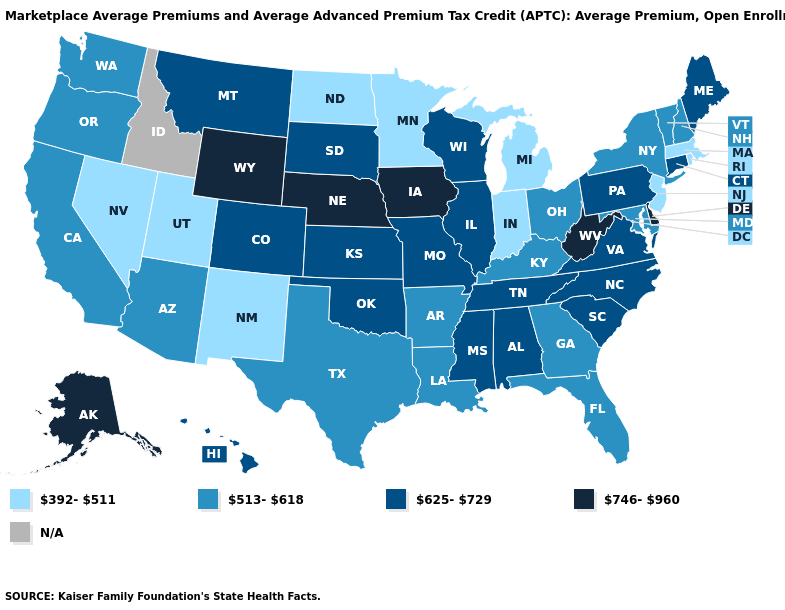What is the lowest value in the USA?
Keep it brief. 392-511. What is the value of Nevada?
Write a very short answer. 392-511. Name the states that have a value in the range 625-729?
Keep it brief. Alabama, Colorado, Connecticut, Hawaii, Illinois, Kansas, Maine, Mississippi, Missouri, Montana, North Carolina, Oklahoma, Pennsylvania, South Carolina, South Dakota, Tennessee, Virginia, Wisconsin. What is the value of West Virginia?
Answer briefly. 746-960. What is the lowest value in the USA?
Short answer required. 392-511. Name the states that have a value in the range 392-511?
Short answer required. Indiana, Massachusetts, Michigan, Minnesota, Nevada, New Jersey, New Mexico, North Dakota, Rhode Island, Utah. What is the highest value in the USA?
Be succinct. 746-960. Among the states that border Indiana , does Michigan have the lowest value?
Be succinct. Yes. Among the states that border Idaho , does Wyoming have the highest value?
Concise answer only. Yes. What is the value of Indiana?
Keep it brief. 392-511. What is the value of Florida?
Quick response, please. 513-618. Name the states that have a value in the range 513-618?
Concise answer only. Arizona, Arkansas, California, Florida, Georgia, Kentucky, Louisiana, Maryland, New Hampshire, New York, Ohio, Oregon, Texas, Vermont, Washington. Does the first symbol in the legend represent the smallest category?
Answer briefly. Yes. 